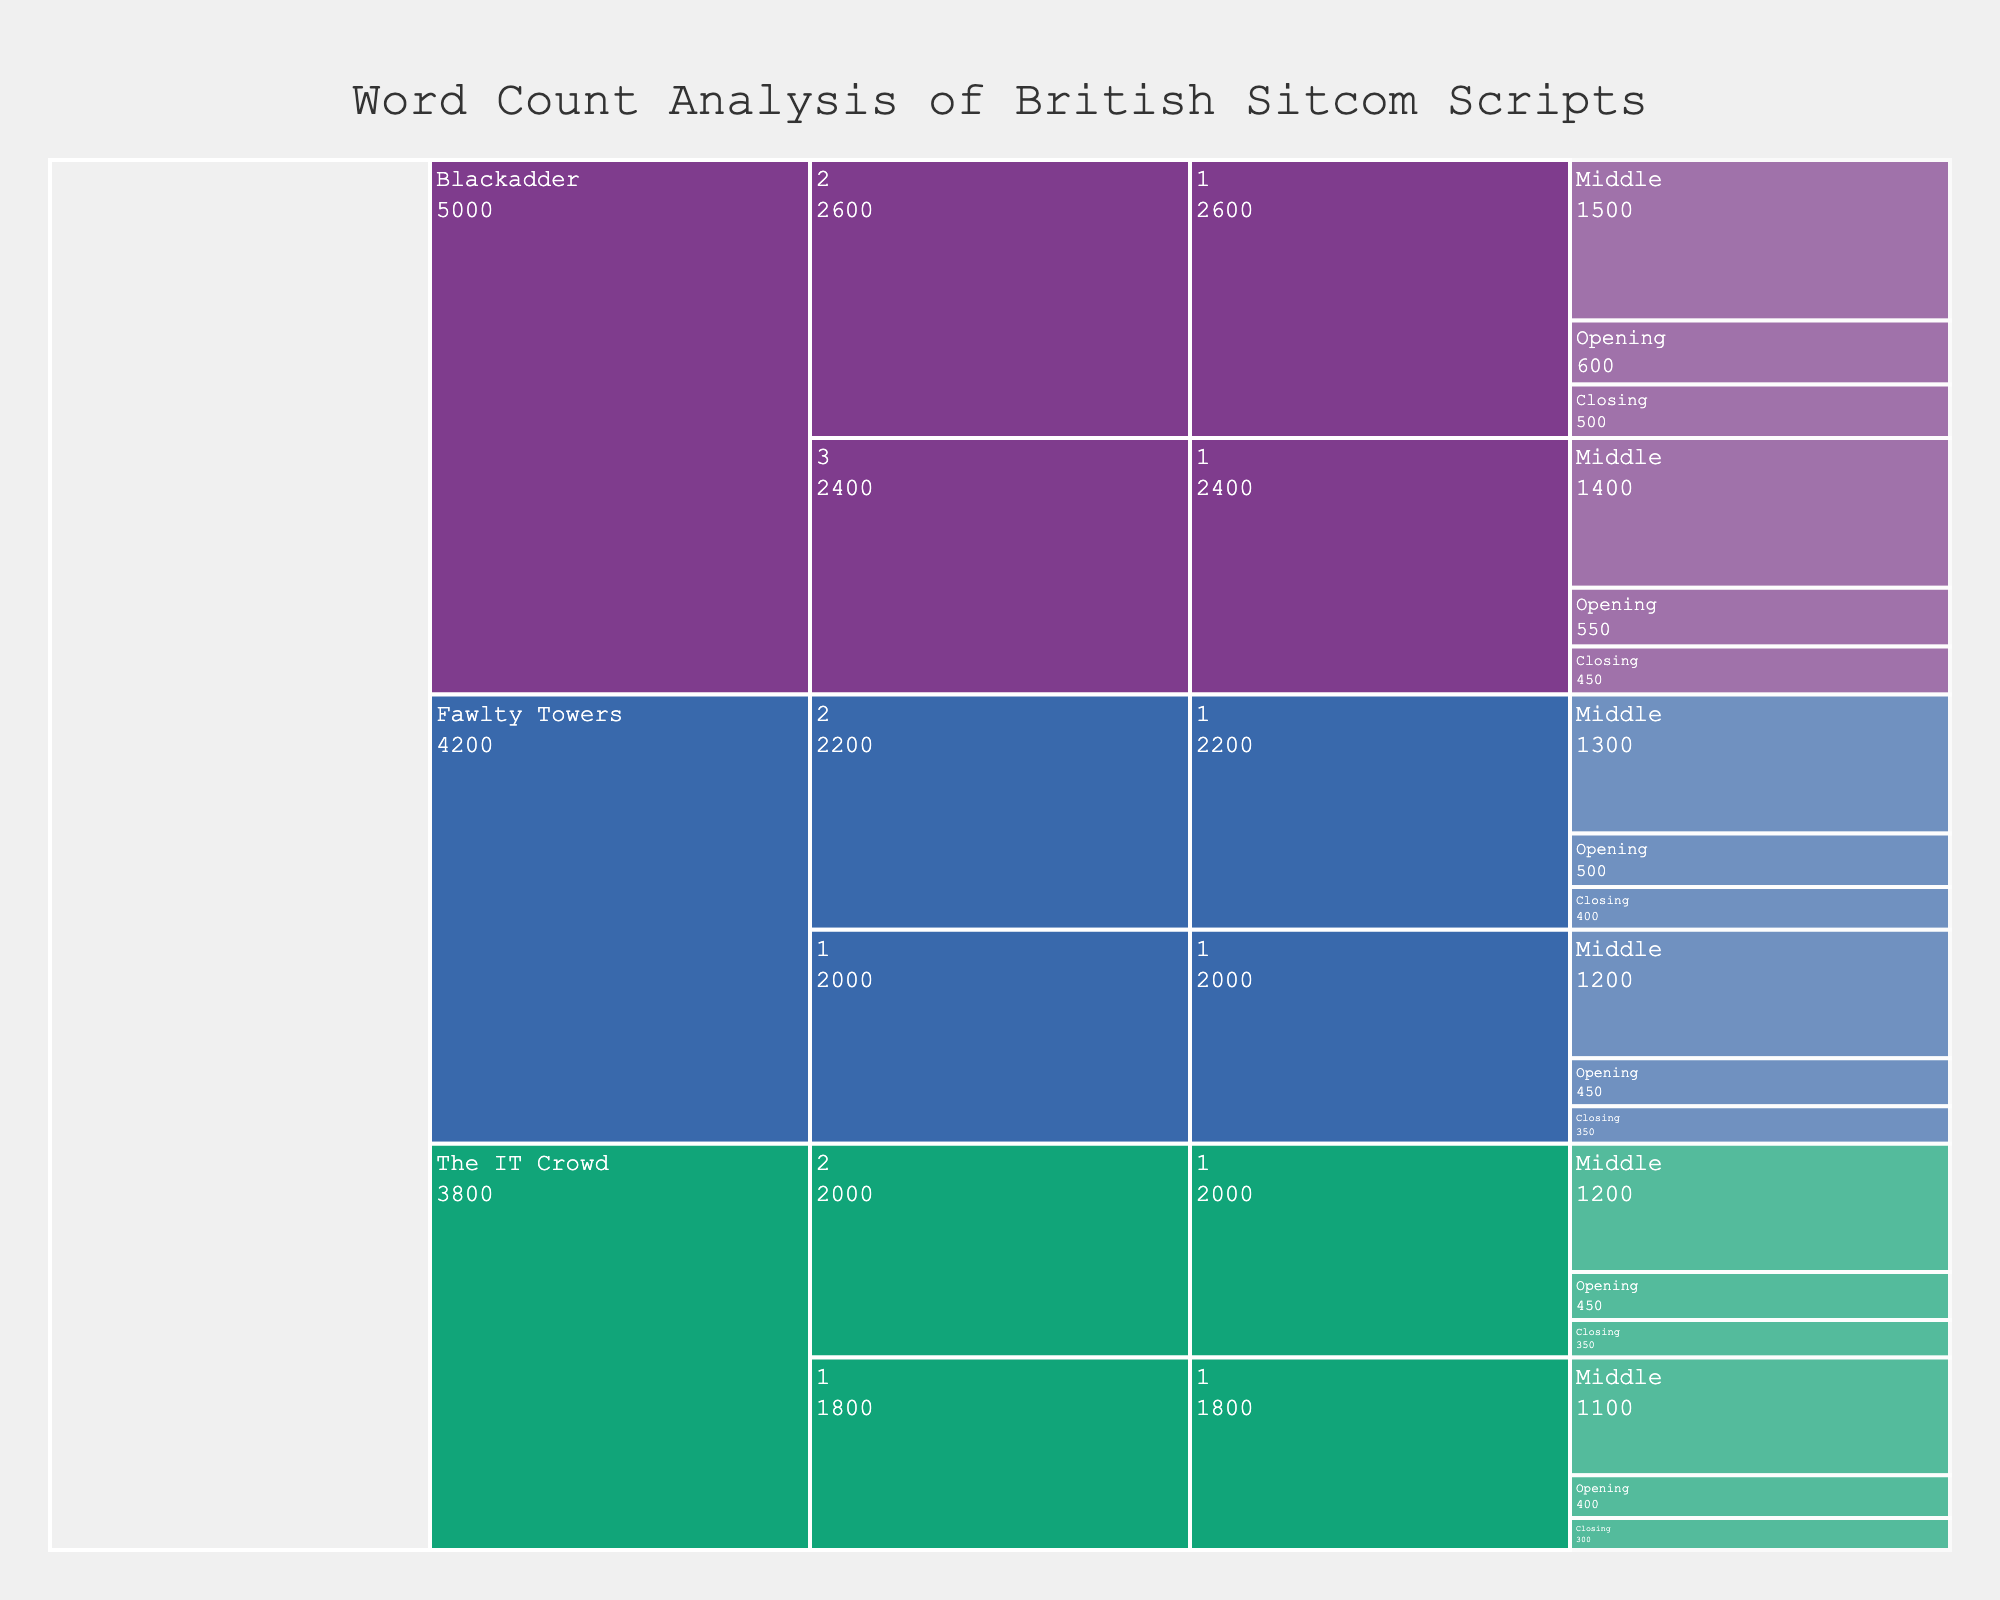What's the title of the chart? The title is prominently displayed at the top center of the icicle chart.
Answer: Word Count Analysis of British Sitcom Scripts How many series are included in the chart? The icicle chart's top level shows distinct sections for different series, each with its own color.
Answer: 3 Which series has the highest word count in the middle of an episode in Season 2? By comparing the word counts for the middle act of each episode in Season 2, you'll notice the values.
Answer: Blackadder What's the total word count for all episodes of The IT Crowd shown in the chart? Sum up all the word counts of The IT Crowd listed in the data across its episodes: (400 + 1100 + 300) + (450 + 1200 + 350).
Answer: 3800 Which act consistently has the lowest word count across all series and episodes? Observe the word counts for each act (Opening, Middle, Closing) and compare.
Answer: Closing Compare the word count of Blackadder's Season 2, Episode 1 with Fawlty Towers' Season 2, Episode 1. Sum the word counts for Opening, Middle, and Closing acts of each episode and compare. Blackadder: 600 + 1500 + 500 = 2600; Fawlty Towers: 500 + 1300 + 400 = 2200.
Answer: Blackadder's word count is higher What is the word count difference between the opening act of The IT Crowd's Season 1, Episode 1 and Blackadder's Season 3, Episode 1? Subtract the smaller word count (The IT Crowd's 400) from the larger one (Blackadder's 550).
Answer: 150 Which series has the highest average word count per act? Calculate the total word count for each series and then divide by the number of acts (3 acts per episode, 1 episode per specified series/season combination). The calculations are:
Fawlty Towers: (450 + 1200 + 350 + 500 + 1300 + 400) / 6, Blackadder: (600 + 1500 + 500 + 550 + 1400 + 450) / 6, The IT Crowd: (400 + 1100 + 300 + 450 + 1200 + 350) / 6. Compare the results.
Answer: Blackadder What's the median word count of the final acts ("Closing") for Fawlty Towers and The IT Crowd? List the Closing word counts for these two series: Fawlty Towers (350, 400) and The IT Crowd (300, 350). Combine and sort them: 300, 350, 350, 400. Take the median of the combined list.
Answer: 350 In which series and season is the word count for an opening act the highest? Compare the opening word counts across all series and seasons listed in the chart.
Answer: Blackadder, Season 2 